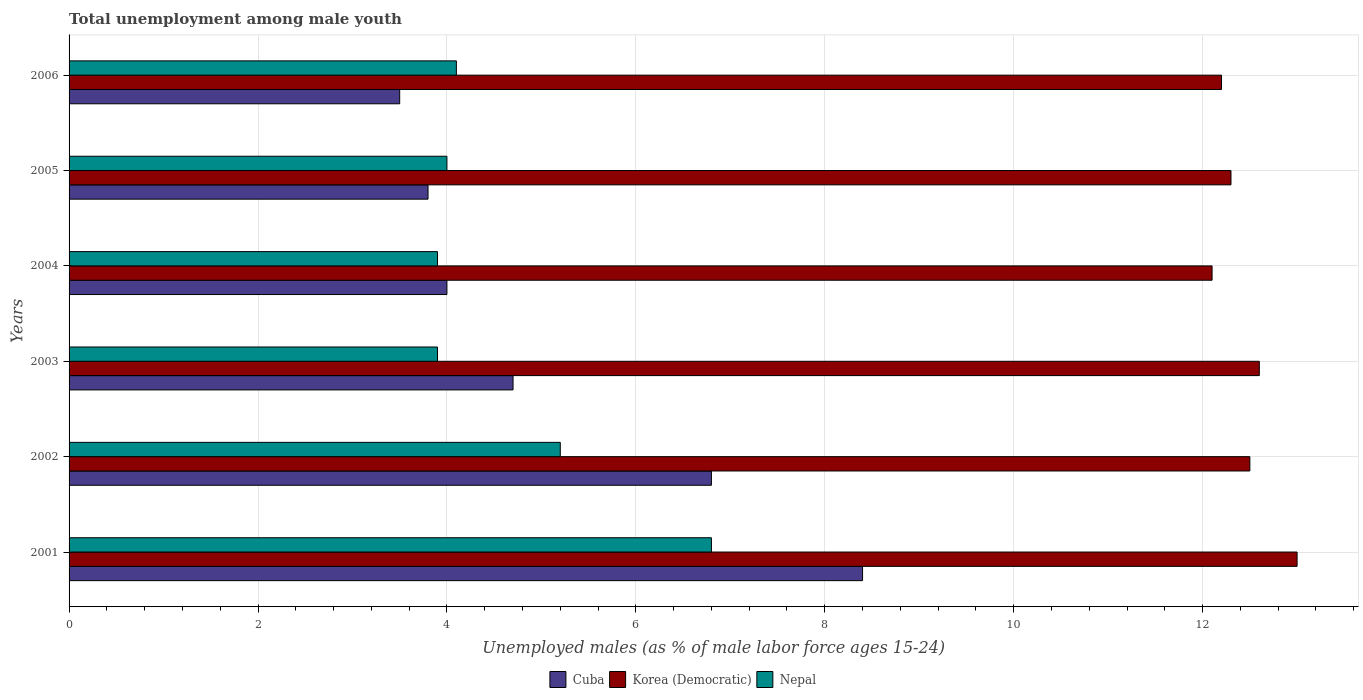Are the number of bars per tick equal to the number of legend labels?
Make the answer very short. Yes. Are the number of bars on each tick of the Y-axis equal?
Ensure brevity in your answer.  Yes. How many bars are there on the 5th tick from the top?
Provide a succinct answer. 3. How many bars are there on the 2nd tick from the bottom?
Give a very brief answer. 3. In how many cases, is the number of bars for a given year not equal to the number of legend labels?
Offer a very short reply. 0. What is the percentage of unemployed males in in Nepal in 2005?
Ensure brevity in your answer.  4. Across all years, what is the maximum percentage of unemployed males in in Cuba?
Offer a terse response. 8.4. What is the total percentage of unemployed males in in Nepal in the graph?
Provide a succinct answer. 27.9. What is the difference between the percentage of unemployed males in in Korea (Democratic) in 2001 and that in 2003?
Make the answer very short. 0.4. What is the difference between the percentage of unemployed males in in Nepal in 2006 and the percentage of unemployed males in in Cuba in 2005?
Provide a succinct answer. 0.3. What is the average percentage of unemployed males in in Cuba per year?
Your response must be concise. 5.2. In the year 2005, what is the difference between the percentage of unemployed males in in Nepal and percentage of unemployed males in in Korea (Democratic)?
Make the answer very short. -8.3. In how many years, is the percentage of unemployed males in in Cuba greater than 11.2 %?
Keep it short and to the point. 0. What is the ratio of the percentage of unemployed males in in Cuba in 2001 to that in 2004?
Offer a very short reply. 2.1. Is the difference between the percentage of unemployed males in in Nepal in 2002 and 2004 greater than the difference between the percentage of unemployed males in in Korea (Democratic) in 2002 and 2004?
Your answer should be very brief. Yes. What is the difference between the highest and the second highest percentage of unemployed males in in Nepal?
Provide a succinct answer. 1.6. What is the difference between the highest and the lowest percentage of unemployed males in in Nepal?
Ensure brevity in your answer.  2.9. Is the sum of the percentage of unemployed males in in Nepal in 2001 and 2002 greater than the maximum percentage of unemployed males in in Cuba across all years?
Offer a very short reply. Yes. What does the 2nd bar from the top in 2003 represents?
Your answer should be compact. Korea (Democratic). What does the 2nd bar from the bottom in 2003 represents?
Provide a short and direct response. Korea (Democratic). How many bars are there?
Keep it short and to the point. 18. Are all the bars in the graph horizontal?
Provide a succinct answer. Yes. What is the difference between two consecutive major ticks on the X-axis?
Ensure brevity in your answer.  2. Are the values on the major ticks of X-axis written in scientific E-notation?
Provide a short and direct response. No. Does the graph contain grids?
Keep it short and to the point. Yes. What is the title of the graph?
Your answer should be very brief. Total unemployment among male youth. What is the label or title of the X-axis?
Your answer should be compact. Unemployed males (as % of male labor force ages 15-24). What is the label or title of the Y-axis?
Provide a succinct answer. Years. What is the Unemployed males (as % of male labor force ages 15-24) in Cuba in 2001?
Your answer should be compact. 8.4. What is the Unemployed males (as % of male labor force ages 15-24) of Korea (Democratic) in 2001?
Your answer should be compact. 13. What is the Unemployed males (as % of male labor force ages 15-24) of Nepal in 2001?
Keep it short and to the point. 6.8. What is the Unemployed males (as % of male labor force ages 15-24) in Cuba in 2002?
Your answer should be very brief. 6.8. What is the Unemployed males (as % of male labor force ages 15-24) in Nepal in 2002?
Your response must be concise. 5.2. What is the Unemployed males (as % of male labor force ages 15-24) in Cuba in 2003?
Provide a succinct answer. 4.7. What is the Unemployed males (as % of male labor force ages 15-24) in Korea (Democratic) in 2003?
Provide a succinct answer. 12.6. What is the Unemployed males (as % of male labor force ages 15-24) in Nepal in 2003?
Give a very brief answer. 3.9. What is the Unemployed males (as % of male labor force ages 15-24) of Korea (Democratic) in 2004?
Keep it short and to the point. 12.1. What is the Unemployed males (as % of male labor force ages 15-24) in Nepal in 2004?
Offer a terse response. 3.9. What is the Unemployed males (as % of male labor force ages 15-24) in Cuba in 2005?
Provide a succinct answer. 3.8. What is the Unemployed males (as % of male labor force ages 15-24) of Korea (Democratic) in 2005?
Ensure brevity in your answer.  12.3. What is the Unemployed males (as % of male labor force ages 15-24) of Nepal in 2005?
Offer a terse response. 4. What is the Unemployed males (as % of male labor force ages 15-24) in Korea (Democratic) in 2006?
Offer a very short reply. 12.2. What is the Unemployed males (as % of male labor force ages 15-24) of Nepal in 2006?
Make the answer very short. 4.1. Across all years, what is the maximum Unemployed males (as % of male labor force ages 15-24) of Cuba?
Provide a short and direct response. 8.4. Across all years, what is the maximum Unemployed males (as % of male labor force ages 15-24) in Korea (Democratic)?
Keep it short and to the point. 13. Across all years, what is the maximum Unemployed males (as % of male labor force ages 15-24) of Nepal?
Keep it short and to the point. 6.8. Across all years, what is the minimum Unemployed males (as % of male labor force ages 15-24) of Cuba?
Offer a very short reply. 3.5. Across all years, what is the minimum Unemployed males (as % of male labor force ages 15-24) in Korea (Democratic)?
Keep it short and to the point. 12.1. Across all years, what is the minimum Unemployed males (as % of male labor force ages 15-24) of Nepal?
Your answer should be very brief. 3.9. What is the total Unemployed males (as % of male labor force ages 15-24) in Cuba in the graph?
Offer a terse response. 31.2. What is the total Unemployed males (as % of male labor force ages 15-24) in Korea (Democratic) in the graph?
Offer a very short reply. 74.7. What is the total Unemployed males (as % of male labor force ages 15-24) in Nepal in the graph?
Offer a terse response. 27.9. What is the difference between the Unemployed males (as % of male labor force ages 15-24) of Cuba in 2001 and that in 2002?
Give a very brief answer. 1.6. What is the difference between the Unemployed males (as % of male labor force ages 15-24) in Nepal in 2001 and that in 2002?
Your answer should be compact. 1.6. What is the difference between the Unemployed males (as % of male labor force ages 15-24) in Cuba in 2001 and that in 2003?
Offer a very short reply. 3.7. What is the difference between the Unemployed males (as % of male labor force ages 15-24) in Cuba in 2001 and that in 2004?
Your answer should be compact. 4.4. What is the difference between the Unemployed males (as % of male labor force ages 15-24) of Nepal in 2001 and that in 2004?
Your response must be concise. 2.9. What is the difference between the Unemployed males (as % of male labor force ages 15-24) in Korea (Democratic) in 2001 and that in 2005?
Your response must be concise. 0.7. What is the difference between the Unemployed males (as % of male labor force ages 15-24) in Nepal in 2001 and that in 2005?
Ensure brevity in your answer.  2.8. What is the difference between the Unemployed males (as % of male labor force ages 15-24) in Korea (Democratic) in 2001 and that in 2006?
Keep it short and to the point. 0.8. What is the difference between the Unemployed males (as % of male labor force ages 15-24) of Nepal in 2001 and that in 2006?
Give a very brief answer. 2.7. What is the difference between the Unemployed males (as % of male labor force ages 15-24) of Cuba in 2002 and that in 2005?
Your answer should be compact. 3. What is the difference between the Unemployed males (as % of male labor force ages 15-24) of Nepal in 2002 and that in 2005?
Your answer should be very brief. 1.2. What is the difference between the Unemployed males (as % of male labor force ages 15-24) of Cuba in 2002 and that in 2006?
Provide a short and direct response. 3.3. What is the difference between the Unemployed males (as % of male labor force ages 15-24) in Korea (Democratic) in 2002 and that in 2006?
Your answer should be compact. 0.3. What is the difference between the Unemployed males (as % of male labor force ages 15-24) of Nepal in 2002 and that in 2006?
Keep it short and to the point. 1.1. What is the difference between the Unemployed males (as % of male labor force ages 15-24) in Nepal in 2003 and that in 2004?
Offer a terse response. 0. What is the difference between the Unemployed males (as % of male labor force ages 15-24) of Nepal in 2003 and that in 2005?
Provide a short and direct response. -0.1. What is the difference between the Unemployed males (as % of male labor force ages 15-24) of Nepal in 2003 and that in 2006?
Provide a short and direct response. -0.2. What is the difference between the Unemployed males (as % of male labor force ages 15-24) of Cuba in 2004 and that in 2005?
Offer a terse response. 0.2. What is the difference between the Unemployed males (as % of male labor force ages 15-24) of Korea (Democratic) in 2004 and that in 2005?
Your answer should be very brief. -0.2. What is the difference between the Unemployed males (as % of male labor force ages 15-24) of Nepal in 2004 and that in 2005?
Provide a succinct answer. -0.1. What is the difference between the Unemployed males (as % of male labor force ages 15-24) of Cuba in 2004 and that in 2006?
Your answer should be compact. 0.5. What is the difference between the Unemployed males (as % of male labor force ages 15-24) in Nepal in 2004 and that in 2006?
Your answer should be very brief. -0.2. What is the difference between the Unemployed males (as % of male labor force ages 15-24) of Cuba in 2005 and that in 2006?
Your answer should be very brief. 0.3. What is the difference between the Unemployed males (as % of male labor force ages 15-24) in Cuba in 2001 and the Unemployed males (as % of male labor force ages 15-24) in Korea (Democratic) in 2002?
Your answer should be compact. -4.1. What is the difference between the Unemployed males (as % of male labor force ages 15-24) in Cuba in 2001 and the Unemployed males (as % of male labor force ages 15-24) in Nepal in 2002?
Provide a short and direct response. 3.2. What is the difference between the Unemployed males (as % of male labor force ages 15-24) of Korea (Democratic) in 2001 and the Unemployed males (as % of male labor force ages 15-24) of Nepal in 2002?
Your answer should be very brief. 7.8. What is the difference between the Unemployed males (as % of male labor force ages 15-24) of Cuba in 2001 and the Unemployed males (as % of male labor force ages 15-24) of Korea (Democratic) in 2003?
Offer a very short reply. -4.2. What is the difference between the Unemployed males (as % of male labor force ages 15-24) of Cuba in 2001 and the Unemployed males (as % of male labor force ages 15-24) of Korea (Democratic) in 2004?
Provide a succinct answer. -3.7. What is the difference between the Unemployed males (as % of male labor force ages 15-24) in Cuba in 2001 and the Unemployed males (as % of male labor force ages 15-24) in Nepal in 2006?
Your answer should be very brief. 4.3. What is the difference between the Unemployed males (as % of male labor force ages 15-24) of Cuba in 2002 and the Unemployed males (as % of male labor force ages 15-24) of Korea (Democratic) in 2003?
Keep it short and to the point. -5.8. What is the difference between the Unemployed males (as % of male labor force ages 15-24) in Cuba in 2002 and the Unemployed males (as % of male labor force ages 15-24) in Nepal in 2003?
Offer a terse response. 2.9. What is the difference between the Unemployed males (as % of male labor force ages 15-24) of Cuba in 2002 and the Unemployed males (as % of male labor force ages 15-24) of Korea (Democratic) in 2004?
Your answer should be very brief. -5.3. What is the difference between the Unemployed males (as % of male labor force ages 15-24) in Cuba in 2002 and the Unemployed males (as % of male labor force ages 15-24) in Nepal in 2004?
Offer a very short reply. 2.9. What is the difference between the Unemployed males (as % of male labor force ages 15-24) in Cuba in 2003 and the Unemployed males (as % of male labor force ages 15-24) in Korea (Democratic) in 2004?
Provide a short and direct response. -7.4. What is the difference between the Unemployed males (as % of male labor force ages 15-24) in Cuba in 2003 and the Unemployed males (as % of male labor force ages 15-24) in Nepal in 2004?
Keep it short and to the point. 0.8. What is the difference between the Unemployed males (as % of male labor force ages 15-24) of Korea (Democratic) in 2003 and the Unemployed males (as % of male labor force ages 15-24) of Nepal in 2004?
Your answer should be very brief. 8.7. What is the difference between the Unemployed males (as % of male labor force ages 15-24) of Cuba in 2003 and the Unemployed males (as % of male labor force ages 15-24) of Korea (Democratic) in 2005?
Provide a short and direct response. -7.6. What is the difference between the Unemployed males (as % of male labor force ages 15-24) of Cuba in 2004 and the Unemployed males (as % of male labor force ages 15-24) of Korea (Democratic) in 2006?
Provide a succinct answer. -8.2. What is the difference between the Unemployed males (as % of male labor force ages 15-24) in Cuba in 2004 and the Unemployed males (as % of male labor force ages 15-24) in Nepal in 2006?
Make the answer very short. -0.1. What is the difference between the Unemployed males (as % of male labor force ages 15-24) of Korea (Democratic) in 2004 and the Unemployed males (as % of male labor force ages 15-24) of Nepal in 2006?
Provide a short and direct response. 8. What is the difference between the Unemployed males (as % of male labor force ages 15-24) of Cuba in 2005 and the Unemployed males (as % of male labor force ages 15-24) of Korea (Democratic) in 2006?
Offer a terse response. -8.4. What is the difference between the Unemployed males (as % of male labor force ages 15-24) in Cuba in 2005 and the Unemployed males (as % of male labor force ages 15-24) in Nepal in 2006?
Your response must be concise. -0.3. What is the average Unemployed males (as % of male labor force ages 15-24) of Korea (Democratic) per year?
Offer a terse response. 12.45. What is the average Unemployed males (as % of male labor force ages 15-24) in Nepal per year?
Offer a very short reply. 4.65. In the year 2001, what is the difference between the Unemployed males (as % of male labor force ages 15-24) in Cuba and Unemployed males (as % of male labor force ages 15-24) in Korea (Democratic)?
Keep it short and to the point. -4.6. In the year 2001, what is the difference between the Unemployed males (as % of male labor force ages 15-24) in Cuba and Unemployed males (as % of male labor force ages 15-24) in Nepal?
Your answer should be very brief. 1.6. In the year 2002, what is the difference between the Unemployed males (as % of male labor force ages 15-24) of Cuba and Unemployed males (as % of male labor force ages 15-24) of Nepal?
Make the answer very short. 1.6. In the year 2004, what is the difference between the Unemployed males (as % of male labor force ages 15-24) in Cuba and Unemployed males (as % of male labor force ages 15-24) in Korea (Democratic)?
Provide a succinct answer. -8.1. In the year 2005, what is the difference between the Unemployed males (as % of male labor force ages 15-24) in Cuba and Unemployed males (as % of male labor force ages 15-24) in Korea (Democratic)?
Provide a short and direct response. -8.5. In the year 2006, what is the difference between the Unemployed males (as % of male labor force ages 15-24) in Cuba and Unemployed males (as % of male labor force ages 15-24) in Nepal?
Make the answer very short. -0.6. What is the ratio of the Unemployed males (as % of male labor force ages 15-24) of Cuba in 2001 to that in 2002?
Ensure brevity in your answer.  1.24. What is the ratio of the Unemployed males (as % of male labor force ages 15-24) in Korea (Democratic) in 2001 to that in 2002?
Keep it short and to the point. 1.04. What is the ratio of the Unemployed males (as % of male labor force ages 15-24) in Nepal in 2001 to that in 2002?
Provide a short and direct response. 1.31. What is the ratio of the Unemployed males (as % of male labor force ages 15-24) of Cuba in 2001 to that in 2003?
Provide a succinct answer. 1.79. What is the ratio of the Unemployed males (as % of male labor force ages 15-24) in Korea (Democratic) in 2001 to that in 2003?
Keep it short and to the point. 1.03. What is the ratio of the Unemployed males (as % of male labor force ages 15-24) in Nepal in 2001 to that in 2003?
Your answer should be compact. 1.74. What is the ratio of the Unemployed males (as % of male labor force ages 15-24) of Korea (Democratic) in 2001 to that in 2004?
Offer a terse response. 1.07. What is the ratio of the Unemployed males (as % of male labor force ages 15-24) in Nepal in 2001 to that in 2004?
Your response must be concise. 1.74. What is the ratio of the Unemployed males (as % of male labor force ages 15-24) of Cuba in 2001 to that in 2005?
Your answer should be very brief. 2.21. What is the ratio of the Unemployed males (as % of male labor force ages 15-24) in Korea (Democratic) in 2001 to that in 2005?
Ensure brevity in your answer.  1.06. What is the ratio of the Unemployed males (as % of male labor force ages 15-24) of Korea (Democratic) in 2001 to that in 2006?
Give a very brief answer. 1.07. What is the ratio of the Unemployed males (as % of male labor force ages 15-24) in Nepal in 2001 to that in 2006?
Offer a very short reply. 1.66. What is the ratio of the Unemployed males (as % of male labor force ages 15-24) in Cuba in 2002 to that in 2003?
Offer a very short reply. 1.45. What is the ratio of the Unemployed males (as % of male labor force ages 15-24) in Cuba in 2002 to that in 2004?
Your answer should be very brief. 1.7. What is the ratio of the Unemployed males (as % of male labor force ages 15-24) in Korea (Democratic) in 2002 to that in 2004?
Ensure brevity in your answer.  1.03. What is the ratio of the Unemployed males (as % of male labor force ages 15-24) of Cuba in 2002 to that in 2005?
Provide a short and direct response. 1.79. What is the ratio of the Unemployed males (as % of male labor force ages 15-24) of Korea (Democratic) in 2002 to that in 2005?
Give a very brief answer. 1.02. What is the ratio of the Unemployed males (as % of male labor force ages 15-24) in Nepal in 2002 to that in 2005?
Give a very brief answer. 1.3. What is the ratio of the Unemployed males (as % of male labor force ages 15-24) of Cuba in 2002 to that in 2006?
Your response must be concise. 1.94. What is the ratio of the Unemployed males (as % of male labor force ages 15-24) in Korea (Democratic) in 2002 to that in 2006?
Ensure brevity in your answer.  1.02. What is the ratio of the Unemployed males (as % of male labor force ages 15-24) in Nepal in 2002 to that in 2006?
Provide a succinct answer. 1.27. What is the ratio of the Unemployed males (as % of male labor force ages 15-24) of Cuba in 2003 to that in 2004?
Your answer should be compact. 1.18. What is the ratio of the Unemployed males (as % of male labor force ages 15-24) in Korea (Democratic) in 2003 to that in 2004?
Ensure brevity in your answer.  1.04. What is the ratio of the Unemployed males (as % of male labor force ages 15-24) in Cuba in 2003 to that in 2005?
Give a very brief answer. 1.24. What is the ratio of the Unemployed males (as % of male labor force ages 15-24) of Korea (Democratic) in 2003 to that in 2005?
Your response must be concise. 1.02. What is the ratio of the Unemployed males (as % of male labor force ages 15-24) in Nepal in 2003 to that in 2005?
Provide a short and direct response. 0.97. What is the ratio of the Unemployed males (as % of male labor force ages 15-24) of Cuba in 2003 to that in 2006?
Ensure brevity in your answer.  1.34. What is the ratio of the Unemployed males (as % of male labor force ages 15-24) in Korea (Democratic) in 2003 to that in 2006?
Make the answer very short. 1.03. What is the ratio of the Unemployed males (as % of male labor force ages 15-24) in Nepal in 2003 to that in 2006?
Make the answer very short. 0.95. What is the ratio of the Unemployed males (as % of male labor force ages 15-24) in Cuba in 2004 to that in 2005?
Give a very brief answer. 1.05. What is the ratio of the Unemployed males (as % of male labor force ages 15-24) in Korea (Democratic) in 2004 to that in 2005?
Provide a succinct answer. 0.98. What is the ratio of the Unemployed males (as % of male labor force ages 15-24) of Cuba in 2004 to that in 2006?
Your answer should be compact. 1.14. What is the ratio of the Unemployed males (as % of male labor force ages 15-24) in Nepal in 2004 to that in 2006?
Offer a very short reply. 0.95. What is the ratio of the Unemployed males (as % of male labor force ages 15-24) of Cuba in 2005 to that in 2006?
Provide a short and direct response. 1.09. What is the ratio of the Unemployed males (as % of male labor force ages 15-24) of Korea (Democratic) in 2005 to that in 2006?
Offer a terse response. 1.01. What is the ratio of the Unemployed males (as % of male labor force ages 15-24) in Nepal in 2005 to that in 2006?
Give a very brief answer. 0.98. What is the difference between the highest and the second highest Unemployed males (as % of male labor force ages 15-24) of Korea (Democratic)?
Your answer should be very brief. 0.4. What is the difference between the highest and the second highest Unemployed males (as % of male labor force ages 15-24) of Nepal?
Ensure brevity in your answer.  1.6. What is the difference between the highest and the lowest Unemployed males (as % of male labor force ages 15-24) of Korea (Democratic)?
Offer a terse response. 0.9. What is the difference between the highest and the lowest Unemployed males (as % of male labor force ages 15-24) of Nepal?
Your response must be concise. 2.9. 